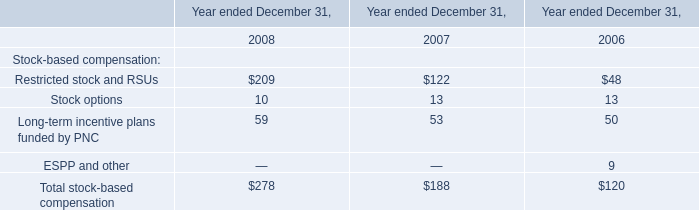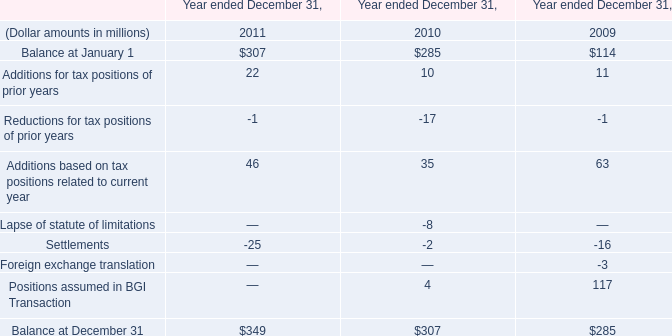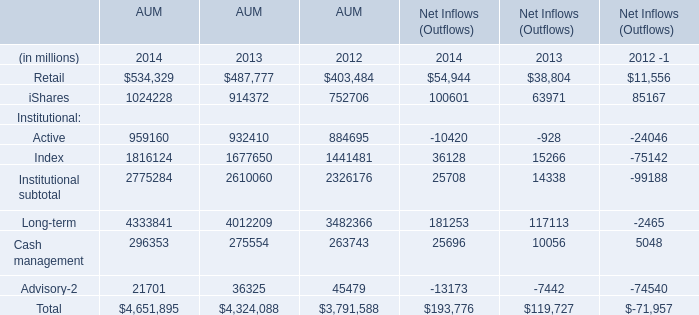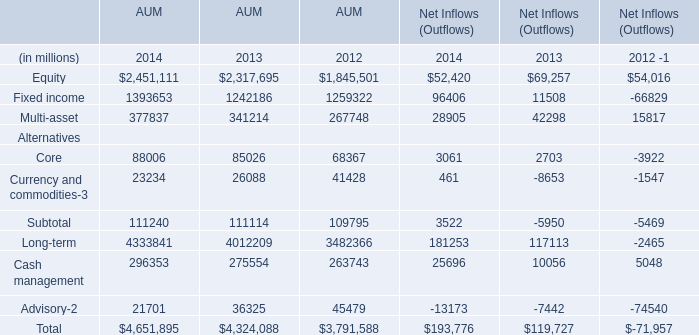What is the growing rate of AUM Index in the year with the most AUM Active? 
Computations: ((1816124 - 1677650) / 1677650)
Answer: 0.08254. 